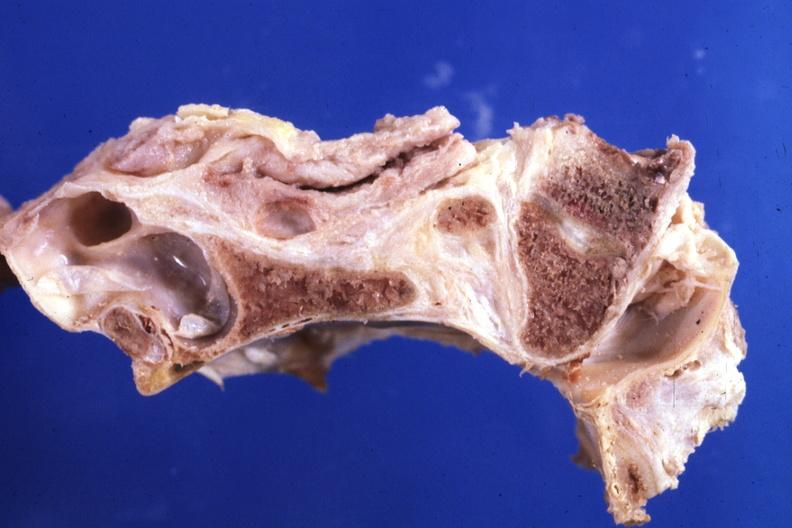does mesothelioma show fixed tissue saggital section stenotic foramen magnum?
Answer the question using a single word or phrase. No 